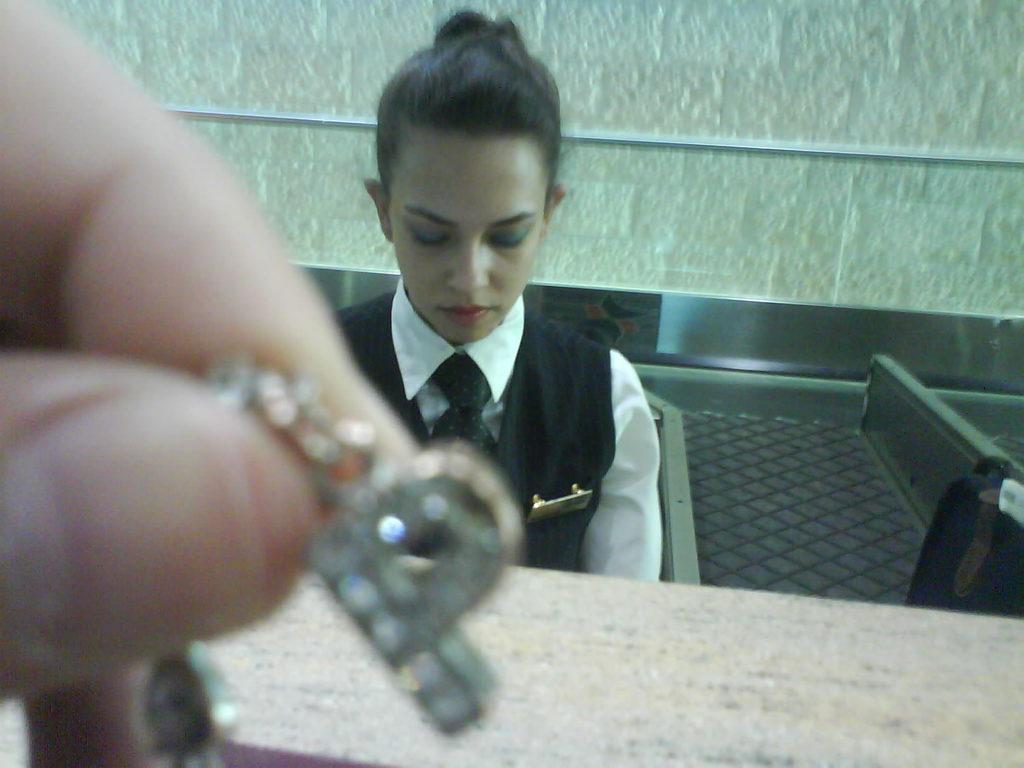How would you summarize this image in a sentence or two? This image is taken indoors. In the background there is a wall. On the left side of the image a person is holding a locket in the hand. In the middle of the image a woman is sitting on the chair and there is a table. 